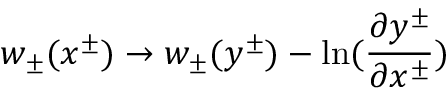Convert formula to latex. <formula><loc_0><loc_0><loc_500><loc_500>w _ { \pm } ( x ^ { \pm } ) \rightarrow w _ { \pm } ( y ^ { \pm } ) - \ln ( { \frac { \partial y ^ { \pm } } { \partial x ^ { \pm } } } )</formula> 